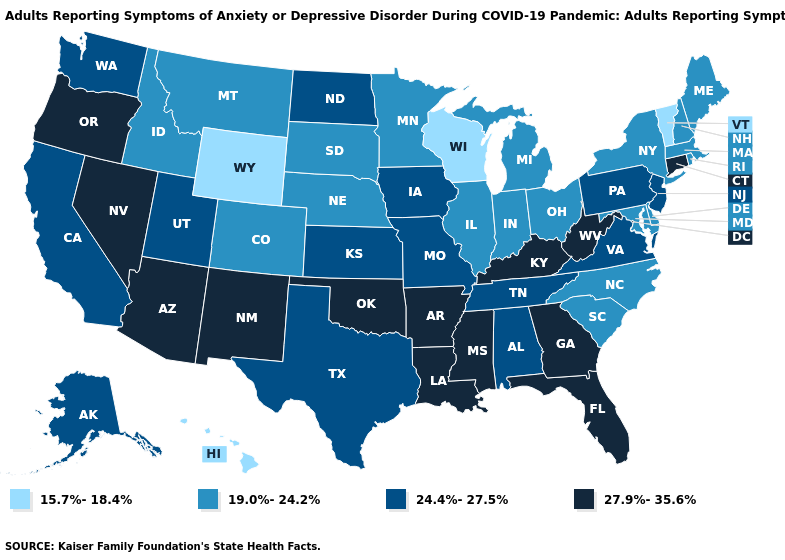Does Virginia have the highest value in the USA?
Be succinct. No. Among the states that border Kansas , does Oklahoma have the highest value?
Give a very brief answer. Yes. Does Vermont have the highest value in the USA?
Short answer required. No. Does Oklahoma have the same value as Florida?
Be succinct. Yes. Name the states that have a value in the range 24.4%-27.5%?
Answer briefly. Alabama, Alaska, California, Iowa, Kansas, Missouri, New Jersey, North Dakota, Pennsylvania, Tennessee, Texas, Utah, Virginia, Washington. Name the states that have a value in the range 27.9%-35.6%?
Answer briefly. Arizona, Arkansas, Connecticut, Florida, Georgia, Kentucky, Louisiana, Mississippi, Nevada, New Mexico, Oklahoma, Oregon, West Virginia. Name the states that have a value in the range 24.4%-27.5%?
Write a very short answer. Alabama, Alaska, California, Iowa, Kansas, Missouri, New Jersey, North Dakota, Pennsylvania, Tennessee, Texas, Utah, Virginia, Washington. What is the value of Alabama?
Write a very short answer. 24.4%-27.5%. Which states have the lowest value in the USA?
Keep it brief. Hawaii, Vermont, Wisconsin, Wyoming. What is the lowest value in the MidWest?
Keep it brief. 15.7%-18.4%. Which states have the lowest value in the USA?
Answer briefly. Hawaii, Vermont, Wisconsin, Wyoming. What is the value of Connecticut?
Concise answer only. 27.9%-35.6%. Among the states that border Kentucky , does West Virginia have the highest value?
Short answer required. Yes. What is the lowest value in the Northeast?
Answer briefly. 15.7%-18.4%. Among the states that border Virginia , does Maryland have the highest value?
Keep it brief. No. 